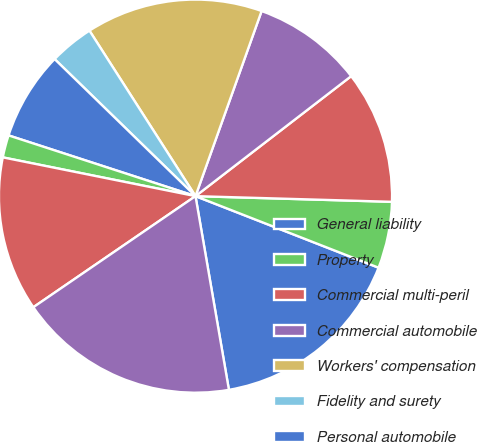Convert chart. <chart><loc_0><loc_0><loc_500><loc_500><pie_chart><fcel>General liability<fcel>Property<fcel>Commercial multi-peril<fcel>Commercial automobile<fcel>Workers' compensation<fcel>Fidelity and surety<fcel>Personal automobile<fcel>Homeowners and personal-other<fcel>International and other<fcel>Property-casualty<nl><fcel>16.35%<fcel>5.47%<fcel>10.91%<fcel>9.09%<fcel>14.53%<fcel>3.65%<fcel>7.28%<fcel>1.84%<fcel>12.72%<fcel>18.16%<nl></chart> 